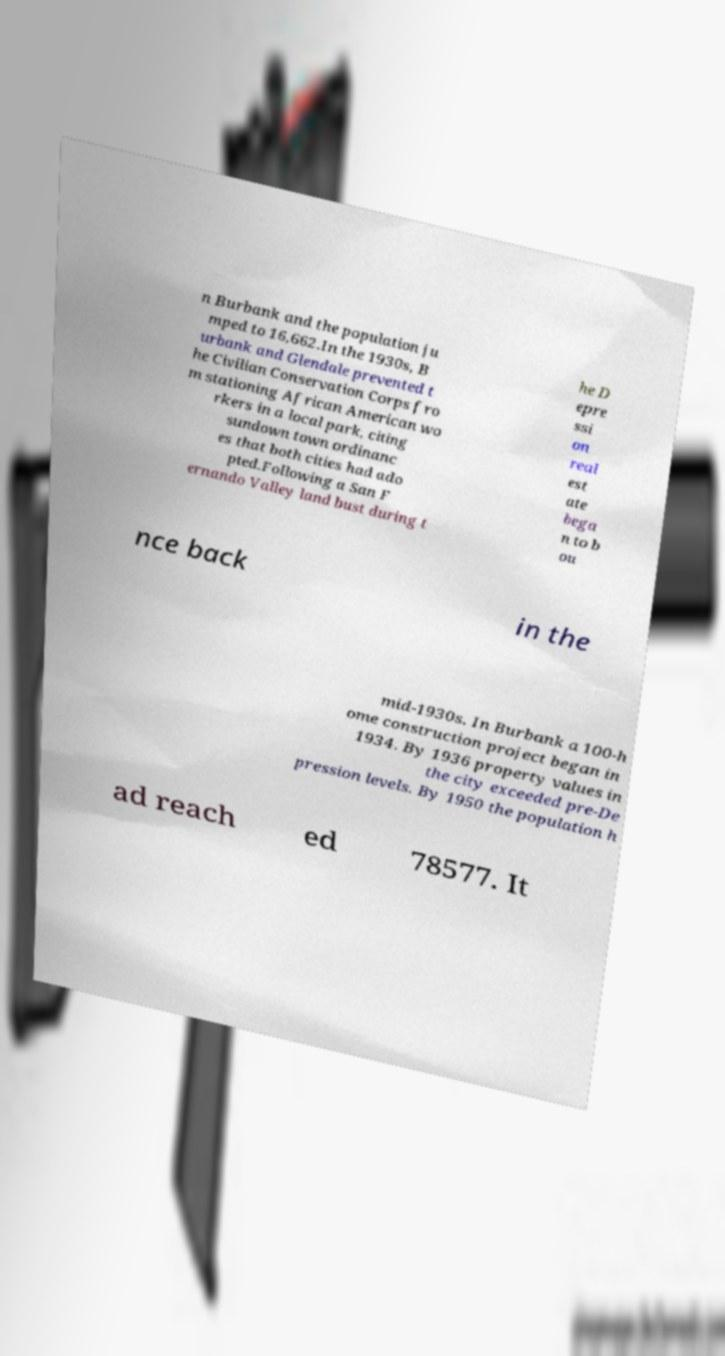Please read and relay the text visible in this image. What does it say? n Burbank and the population ju mped to 16,662.In the 1930s, B urbank and Glendale prevented t he Civilian Conservation Corps fro m stationing African American wo rkers in a local park, citing sundown town ordinanc es that both cities had ado pted.Following a San F ernando Valley land bust during t he D epre ssi on real est ate bega n to b ou nce back in the mid-1930s. In Burbank a 100-h ome construction project began in 1934. By 1936 property values in the city exceeded pre-De pression levels. By 1950 the population h ad reach ed 78577. It 